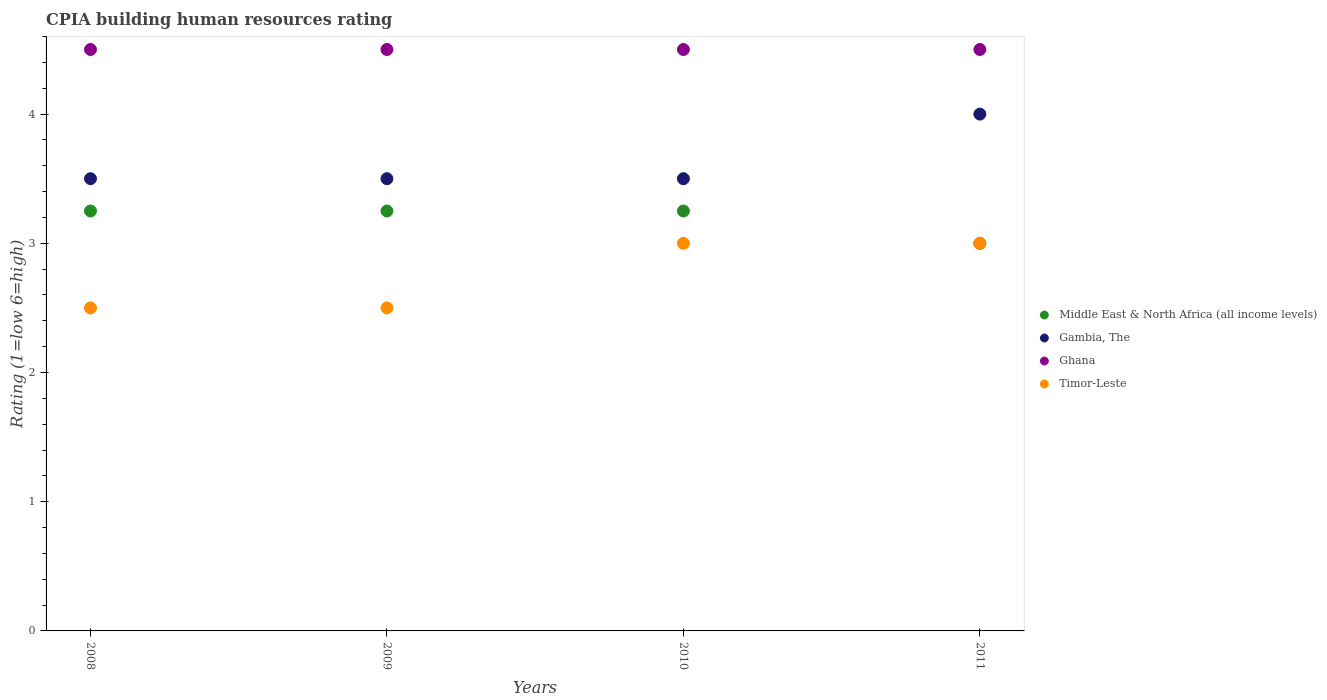How many different coloured dotlines are there?
Offer a very short reply. 4. Is the number of dotlines equal to the number of legend labels?
Give a very brief answer. Yes. Across all years, what is the minimum CPIA rating in Ghana?
Give a very brief answer. 4.5. In which year was the CPIA rating in Ghana maximum?
Your response must be concise. 2008. What is the difference between the CPIA rating in Ghana in 2009 and the CPIA rating in Middle East & North Africa (all income levels) in 2008?
Provide a short and direct response. 1.25. What is the average CPIA rating in Middle East & North Africa (all income levels) per year?
Provide a short and direct response. 3.19. In how many years, is the CPIA rating in Gambia, The greater than 1?
Offer a terse response. 4. What is the ratio of the CPIA rating in Middle East & North Africa (all income levels) in 2008 to that in 2010?
Give a very brief answer. 1. Does the CPIA rating in Middle East & North Africa (all income levels) monotonically increase over the years?
Provide a succinct answer. No. Is the CPIA rating in Middle East & North Africa (all income levels) strictly greater than the CPIA rating in Timor-Leste over the years?
Provide a short and direct response. No. How many dotlines are there?
Your response must be concise. 4. Are the values on the major ticks of Y-axis written in scientific E-notation?
Your response must be concise. No. Does the graph contain grids?
Keep it short and to the point. No. How many legend labels are there?
Provide a succinct answer. 4. How are the legend labels stacked?
Make the answer very short. Vertical. What is the title of the graph?
Your answer should be very brief. CPIA building human resources rating. Does "Vietnam" appear as one of the legend labels in the graph?
Provide a short and direct response. No. What is the label or title of the Y-axis?
Offer a very short reply. Rating (1=low 6=high). What is the Rating (1=low 6=high) of Middle East & North Africa (all income levels) in 2008?
Ensure brevity in your answer.  3.25. What is the Rating (1=low 6=high) of Gambia, The in 2009?
Make the answer very short. 3.5. What is the Rating (1=low 6=high) in Ghana in 2010?
Your answer should be compact. 4.5. What is the Rating (1=low 6=high) in Middle East & North Africa (all income levels) in 2011?
Provide a succinct answer. 3. What is the Rating (1=low 6=high) of Timor-Leste in 2011?
Your answer should be compact. 3. Across all years, what is the maximum Rating (1=low 6=high) in Middle East & North Africa (all income levels)?
Your response must be concise. 3.25. Across all years, what is the maximum Rating (1=low 6=high) of Ghana?
Give a very brief answer. 4.5. Across all years, what is the minimum Rating (1=low 6=high) in Gambia, The?
Offer a terse response. 3.5. Across all years, what is the minimum Rating (1=low 6=high) in Ghana?
Make the answer very short. 4.5. What is the total Rating (1=low 6=high) of Middle East & North Africa (all income levels) in the graph?
Keep it short and to the point. 12.75. What is the total Rating (1=low 6=high) in Timor-Leste in the graph?
Make the answer very short. 11. What is the difference between the Rating (1=low 6=high) in Middle East & North Africa (all income levels) in 2008 and that in 2009?
Provide a short and direct response. 0. What is the difference between the Rating (1=low 6=high) of Gambia, The in 2008 and that in 2009?
Your answer should be compact. 0. What is the difference between the Rating (1=low 6=high) in Timor-Leste in 2008 and that in 2009?
Provide a succinct answer. 0. What is the difference between the Rating (1=low 6=high) in Middle East & North Africa (all income levels) in 2008 and that in 2010?
Keep it short and to the point. 0. What is the difference between the Rating (1=low 6=high) in Gambia, The in 2008 and that in 2010?
Your answer should be compact. 0. What is the difference between the Rating (1=low 6=high) of Timor-Leste in 2008 and that in 2010?
Your response must be concise. -0.5. What is the difference between the Rating (1=low 6=high) of Middle East & North Africa (all income levels) in 2008 and that in 2011?
Your answer should be compact. 0.25. What is the difference between the Rating (1=low 6=high) of Gambia, The in 2008 and that in 2011?
Offer a terse response. -0.5. What is the difference between the Rating (1=low 6=high) of Ghana in 2008 and that in 2011?
Make the answer very short. 0. What is the difference between the Rating (1=low 6=high) of Ghana in 2009 and that in 2010?
Offer a terse response. 0. What is the difference between the Rating (1=low 6=high) in Timor-Leste in 2009 and that in 2010?
Your response must be concise. -0.5. What is the difference between the Rating (1=low 6=high) of Middle East & North Africa (all income levels) in 2009 and that in 2011?
Offer a very short reply. 0.25. What is the difference between the Rating (1=low 6=high) in Gambia, The in 2009 and that in 2011?
Offer a very short reply. -0.5. What is the difference between the Rating (1=low 6=high) in Gambia, The in 2010 and that in 2011?
Offer a very short reply. -0.5. What is the difference between the Rating (1=low 6=high) in Ghana in 2010 and that in 2011?
Keep it short and to the point. 0. What is the difference between the Rating (1=low 6=high) in Middle East & North Africa (all income levels) in 2008 and the Rating (1=low 6=high) in Gambia, The in 2009?
Your response must be concise. -0.25. What is the difference between the Rating (1=low 6=high) in Middle East & North Africa (all income levels) in 2008 and the Rating (1=low 6=high) in Ghana in 2009?
Your answer should be very brief. -1.25. What is the difference between the Rating (1=low 6=high) of Middle East & North Africa (all income levels) in 2008 and the Rating (1=low 6=high) of Timor-Leste in 2009?
Give a very brief answer. 0.75. What is the difference between the Rating (1=low 6=high) in Middle East & North Africa (all income levels) in 2008 and the Rating (1=low 6=high) in Gambia, The in 2010?
Your response must be concise. -0.25. What is the difference between the Rating (1=low 6=high) of Middle East & North Africa (all income levels) in 2008 and the Rating (1=low 6=high) of Ghana in 2010?
Offer a terse response. -1.25. What is the difference between the Rating (1=low 6=high) in Middle East & North Africa (all income levels) in 2008 and the Rating (1=low 6=high) in Timor-Leste in 2010?
Your answer should be compact. 0.25. What is the difference between the Rating (1=low 6=high) of Gambia, The in 2008 and the Rating (1=low 6=high) of Ghana in 2010?
Offer a very short reply. -1. What is the difference between the Rating (1=low 6=high) in Gambia, The in 2008 and the Rating (1=low 6=high) in Timor-Leste in 2010?
Your answer should be compact. 0.5. What is the difference between the Rating (1=low 6=high) of Ghana in 2008 and the Rating (1=low 6=high) of Timor-Leste in 2010?
Give a very brief answer. 1.5. What is the difference between the Rating (1=low 6=high) of Middle East & North Africa (all income levels) in 2008 and the Rating (1=low 6=high) of Gambia, The in 2011?
Ensure brevity in your answer.  -0.75. What is the difference between the Rating (1=low 6=high) of Middle East & North Africa (all income levels) in 2008 and the Rating (1=low 6=high) of Ghana in 2011?
Your answer should be compact. -1.25. What is the difference between the Rating (1=low 6=high) of Gambia, The in 2008 and the Rating (1=low 6=high) of Timor-Leste in 2011?
Keep it short and to the point. 0.5. What is the difference between the Rating (1=low 6=high) in Ghana in 2008 and the Rating (1=low 6=high) in Timor-Leste in 2011?
Your answer should be very brief. 1.5. What is the difference between the Rating (1=low 6=high) of Middle East & North Africa (all income levels) in 2009 and the Rating (1=low 6=high) of Gambia, The in 2010?
Ensure brevity in your answer.  -0.25. What is the difference between the Rating (1=low 6=high) of Middle East & North Africa (all income levels) in 2009 and the Rating (1=low 6=high) of Ghana in 2010?
Your answer should be compact. -1.25. What is the difference between the Rating (1=low 6=high) in Ghana in 2009 and the Rating (1=low 6=high) in Timor-Leste in 2010?
Provide a succinct answer. 1.5. What is the difference between the Rating (1=low 6=high) of Middle East & North Africa (all income levels) in 2009 and the Rating (1=low 6=high) of Gambia, The in 2011?
Offer a terse response. -0.75. What is the difference between the Rating (1=low 6=high) of Middle East & North Africa (all income levels) in 2009 and the Rating (1=low 6=high) of Ghana in 2011?
Make the answer very short. -1.25. What is the difference between the Rating (1=low 6=high) in Gambia, The in 2009 and the Rating (1=low 6=high) in Ghana in 2011?
Provide a short and direct response. -1. What is the difference between the Rating (1=low 6=high) of Ghana in 2009 and the Rating (1=low 6=high) of Timor-Leste in 2011?
Keep it short and to the point. 1.5. What is the difference between the Rating (1=low 6=high) in Middle East & North Africa (all income levels) in 2010 and the Rating (1=low 6=high) in Gambia, The in 2011?
Provide a short and direct response. -0.75. What is the difference between the Rating (1=low 6=high) of Middle East & North Africa (all income levels) in 2010 and the Rating (1=low 6=high) of Ghana in 2011?
Your answer should be very brief. -1.25. What is the difference between the Rating (1=low 6=high) of Gambia, The in 2010 and the Rating (1=low 6=high) of Timor-Leste in 2011?
Provide a short and direct response. 0.5. What is the average Rating (1=low 6=high) in Middle East & North Africa (all income levels) per year?
Give a very brief answer. 3.19. What is the average Rating (1=low 6=high) in Gambia, The per year?
Provide a short and direct response. 3.62. What is the average Rating (1=low 6=high) of Ghana per year?
Provide a succinct answer. 4.5. What is the average Rating (1=low 6=high) in Timor-Leste per year?
Give a very brief answer. 2.75. In the year 2008, what is the difference between the Rating (1=low 6=high) of Middle East & North Africa (all income levels) and Rating (1=low 6=high) of Gambia, The?
Your response must be concise. -0.25. In the year 2008, what is the difference between the Rating (1=low 6=high) in Middle East & North Africa (all income levels) and Rating (1=low 6=high) in Ghana?
Your response must be concise. -1.25. In the year 2008, what is the difference between the Rating (1=low 6=high) of Middle East & North Africa (all income levels) and Rating (1=low 6=high) of Timor-Leste?
Your response must be concise. 0.75. In the year 2009, what is the difference between the Rating (1=low 6=high) of Middle East & North Africa (all income levels) and Rating (1=low 6=high) of Gambia, The?
Your answer should be compact. -0.25. In the year 2009, what is the difference between the Rating (1=low 6=high) of Middle East & North Africa (all income levels) and Rating (1=low 6=high) of Ghana?
Your answer should be compact. -1.25. In the year 2010, what is the difference between the Rating (1=low 6=high) in Middle East & North Africa (all income levels) and Rating (1=low 6=high) in Gambia, The?
Make the answer very short. -0.25. In the year 2010, what is the difference between the Rating (1=low 6=high) in Middle East & North Africa (all income levels) and Rating (1=low 6=high) in Ghana?
Your answer should be very brief. -1.25. In the year 2011, what is the difference between the Rating (1=low 6=high) of Middle East & North Africa (all income levels) and Rating (1=low 6=high) of Ghana?
Your answer should be very brief. -1.5. In the year 2011, what is the difference between the Rating (1=low 6=high) of Middle East & North Africa (all income levels) and Rating (1=low 6=high) of Timor-Leste?
Offer a terse response. 0. In the year 2011, what is the difference between the Rating (1=low 6=high) of Gambia, The and Rating (1=low 6=high) of Ghana?
Offer a very short reply. -0.5. In the year 2011, what is the difference between the Rating (1=low 6=high) in Gambia, The and Rating (1=low 6=high) in Timor-Leste?
Make the answer very short. 1. What is the ratio of the Rating (1=low 6=high) in Middle East & North Africa (all income levels) in 2008 to that in 2009?
Your answer should be compact. 1. What is the ratio of the Rating (1=low 6=high) of Gambia, The in 2008 to that in 2009?
Provide a short and direct response. 1. What is the ratio of the Rating (1=low 6=high) in Gambia, The in 2008 to that in 2010?
Make the answer very short. 1. What is the ratio of the Rating (1=low 6=high) in Ghana in 2008 to that in 2010?
Your response must be concise. 1. What is the ratio of the Rating (1=low 6=high) of Timor-Leste in 2008 to that in 2011?
Your answer should be very brief. 0.83. What is the ratio of the Rating (1=low 6=high) in Ghana in 2009 to that in 2010?
Your response must be concise. 1. What is the ratio of the Rating (1=low 6=high) in Middle East & North Africa (all income levels) in 2009 to that in 2011?
Offer a very short reply. 1.08. What is the ratio of the Rating (1=low 6=high) in Ghana in 2009 to that in 2011?
Offer a very short reply. 1. What is the ratio of the Rating (1=low 6=high) of Timor-Leste in 2009 to that in 2011?
Provide a short and direct response. 0.83. What is the ratio of the Rating (1=low 6=high) of Middle East & North Africa (all income levels) in 2010 to that in 2011?
Your response must be concise. 1.08. What is the ratio of the Rating (1=low 6=high) in Gambia, The in 2010 to that in 2011?
Your answer should be very brief. 0.88. What is the ratio of the Rating (1=low 6=high) in Ghana in 2010 to that in 2011?
Offer a very short reply. 1. What is the ratio of the Rating (1=low 6=high) of Timor-Leste in 2010 to that in 2011?
Your response must be concise. 1. What is the difference between the highest and the second highest Rating (1=low 6=high) in Ghana?
Provide a succinct answer. 0. 